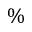<formula> <loc_0><loc_0><loc_500><loc_500>\%</formula> 